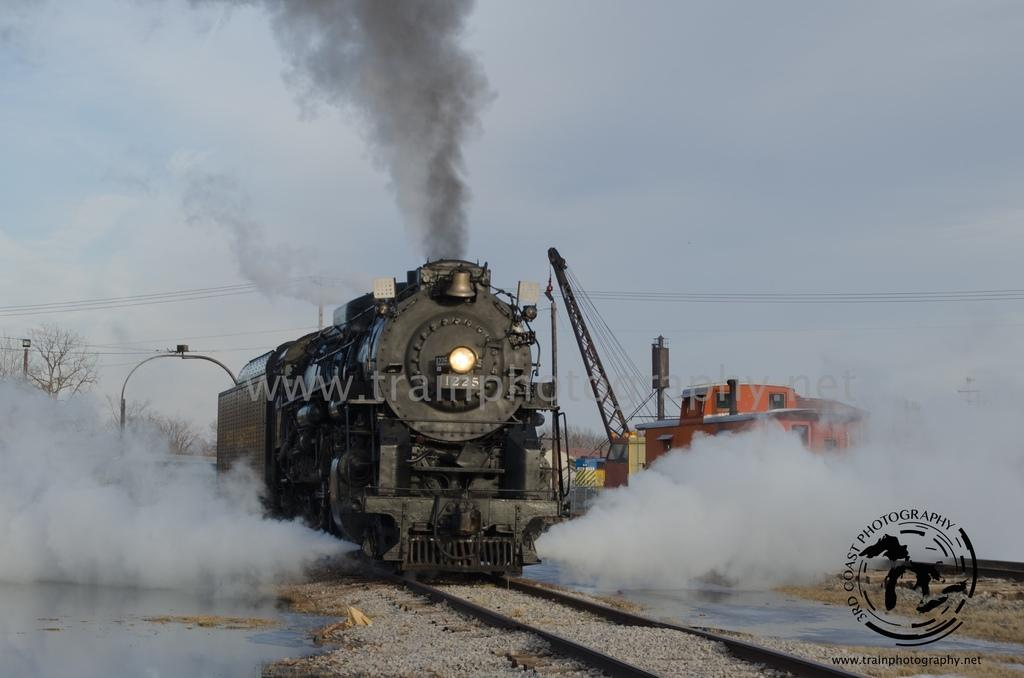What is the main subject of the image? The main subject of the image is a train on the railway track. What other objects or structures can be seen in the image? There is a construction crane, electric poles, cables, trees, and stones visible in the image. What is the condition of the sky in the image? The sky is visible in the image. Is there any indication of activity or movement in the image? Yes, the train on the railway track and the construction crane suggest activity, and the smoke indicates movement. What type of wren can be seen perched on the construction crane in the image? There is no wren present in the image; it features a train on the railway track, a construction crane, electric poles, cables, trees, stones, and a visible sky. 